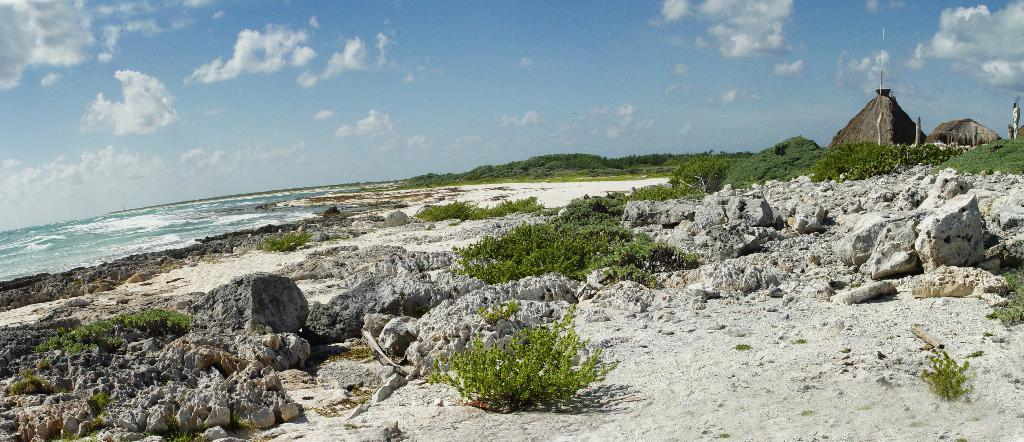What type of terrain is depicted in the image? The image contains sand, rocks, plants, and trees, suggesting a natural landscape. What type of structures are present in the image? There are huts in the image. What natural element is visible in the image? There is water visible in the image. What is visible in the background of the image? The sky is visible in the background of the image, with clouds present. Can you see a ring being worn by any of the plants in the image? There are no rings visible in the image, nor are there any people or animals wearing rings. How does the cannon affect the landscape in the image? There is no cannon present in the image, so it cannot affect the landscape. 